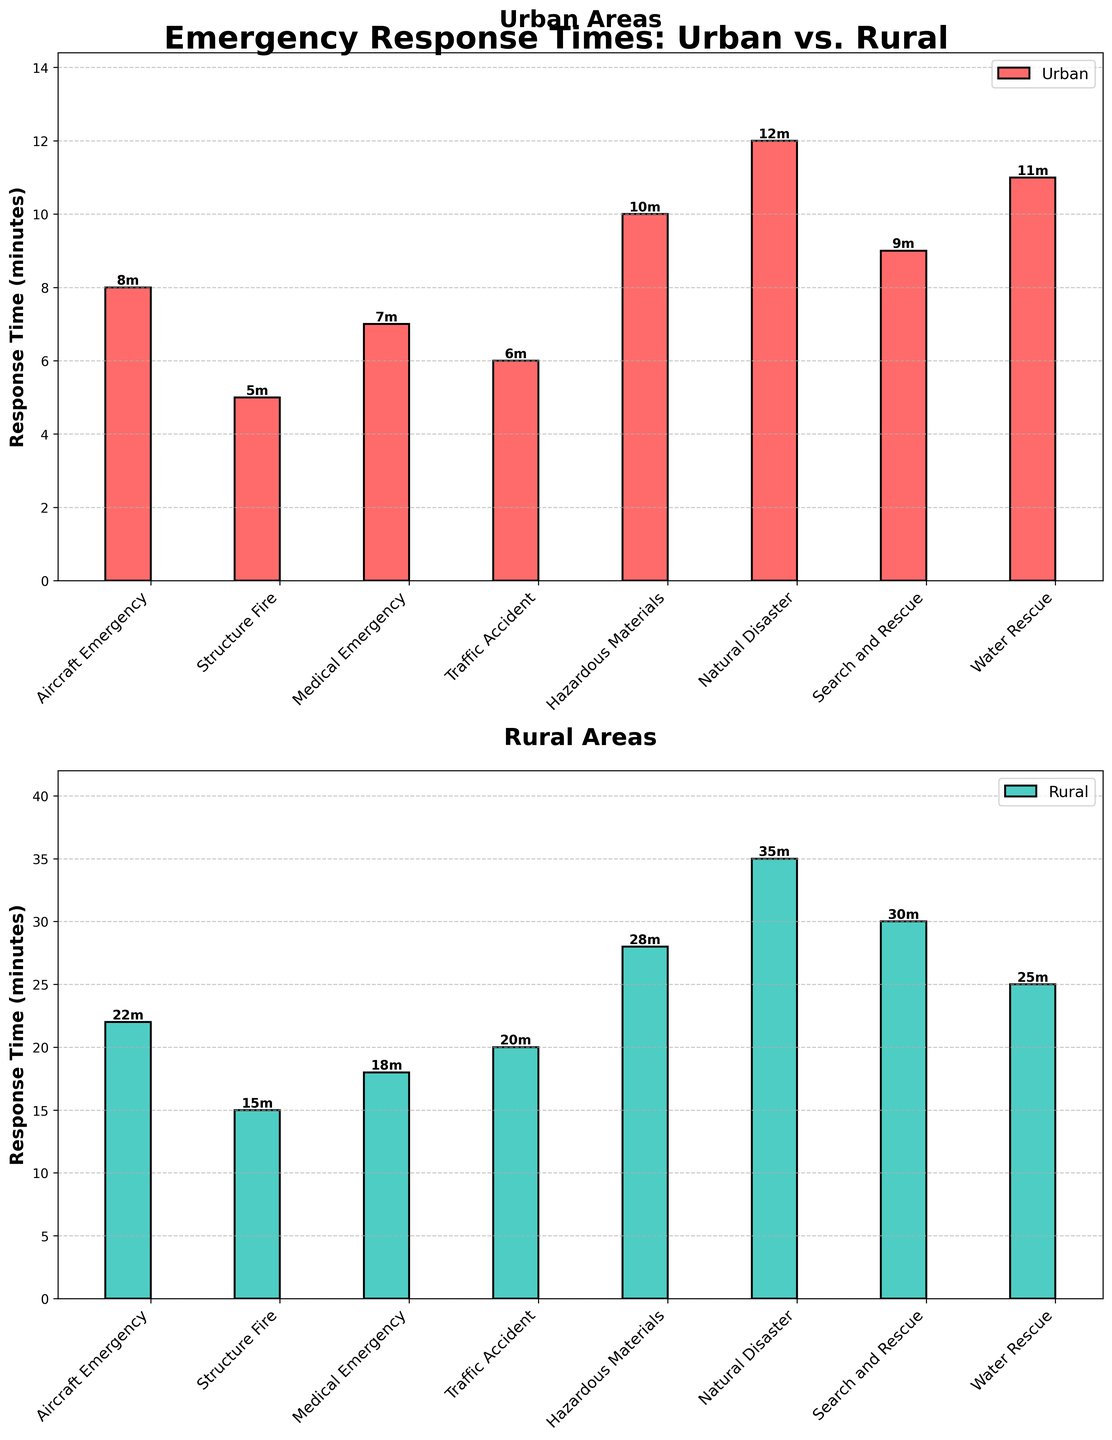What's the title of the figure? The title of the figure can be found at the top, indicating what the figure is about.
Answer: Emergency Response Times: Urban vs. Rural What is the response time for "Structure Fire" in rural areas? To find this, look at the rural subplot and find the bar that corresponds to "Structure Fire".
Answer: 15 minutes What is the difference in response time for "Aircraft Emergency" between urban and rural areas? To find the difference, identify the response times for "Aircraft Emergency" in both subplots and subtract the urban value from the rural value: 22 minutes (rural) - 8 minutes (urban) = 14 minutes.
Answer: 14 minutes Which incident type has the longest response time in rural areas? Scan the rural subplot and identify the tallest bar, which represents the incident type with the longest response time. In this case, it's "Natural Disaster".
Answer: Natural Disaster On average, which area has a faster response time for "Medical Emergency"? Identify and compare the response times in both the urban and rural subplots for "Medical Emergency". The urban time is 7 minutes and the rural time is 18 minutes. Urban is faster.
Answer: Urban How many incident types have a response time over 20 minutes in rural areas? Count the number of bars in the rural subplot that have a height greater than 20 minutes. There are 4 incident types: "Aircraft Emergency", "Traffic Accident", "Hazardous Materials", and "Natural Disaster".
Answer: 4 What is the combined response time for "Search and Rescue" in urban and rural areas? Add the response times for "Search and Rescue" from both subplots: 9 minutes (urban) + 30 minutes (rural) = 39 minutes.
Answer: 39 minutes For "Water Rescue", which area has a faster response time, and by how much? Identify the response times for "Water Rescue" in both subplots. Urban is 11 minutes and rural is 25 minutes. To find the difference, subtract the urban value from the rural value: 25 - 11 = 14 minutes. Urban is faster by 14 minutes.
Answer: Urban by 14 minutes Which incident type has the smallest difference in response times between urban and rural areas? Calculate the difference for each incident type by subtracting the urban response time from the rural response time. The incident with the smallest difference is "Structure Fire" with a difference of 10 minutes (15-5).
Answer: Structure Fire What can be inferred about the general trend of response times between urban and rural areas? Look at the overall pattern across both subplots. Rural areas consistently have longer response times across all incident types compared to urban areas.
Answer: Rural areas have longer response times 